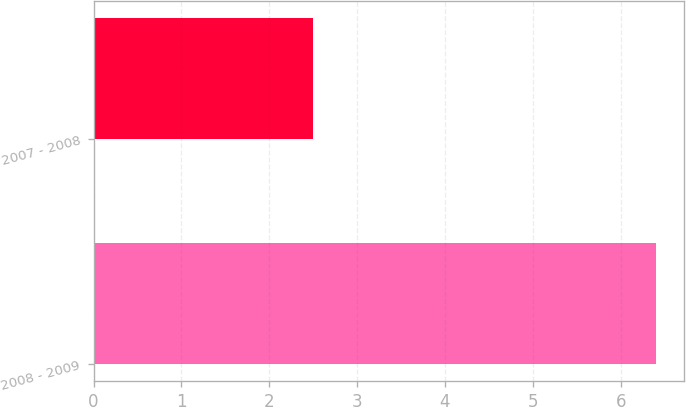Convert chart. <chart><loc_0><loc_0><loc_500><loc_500><bar_chart><fcel>2008 - 2009<fcel>2007 - 2008<nl><fcel>6.4<fcel>2.5<nl></chart> 